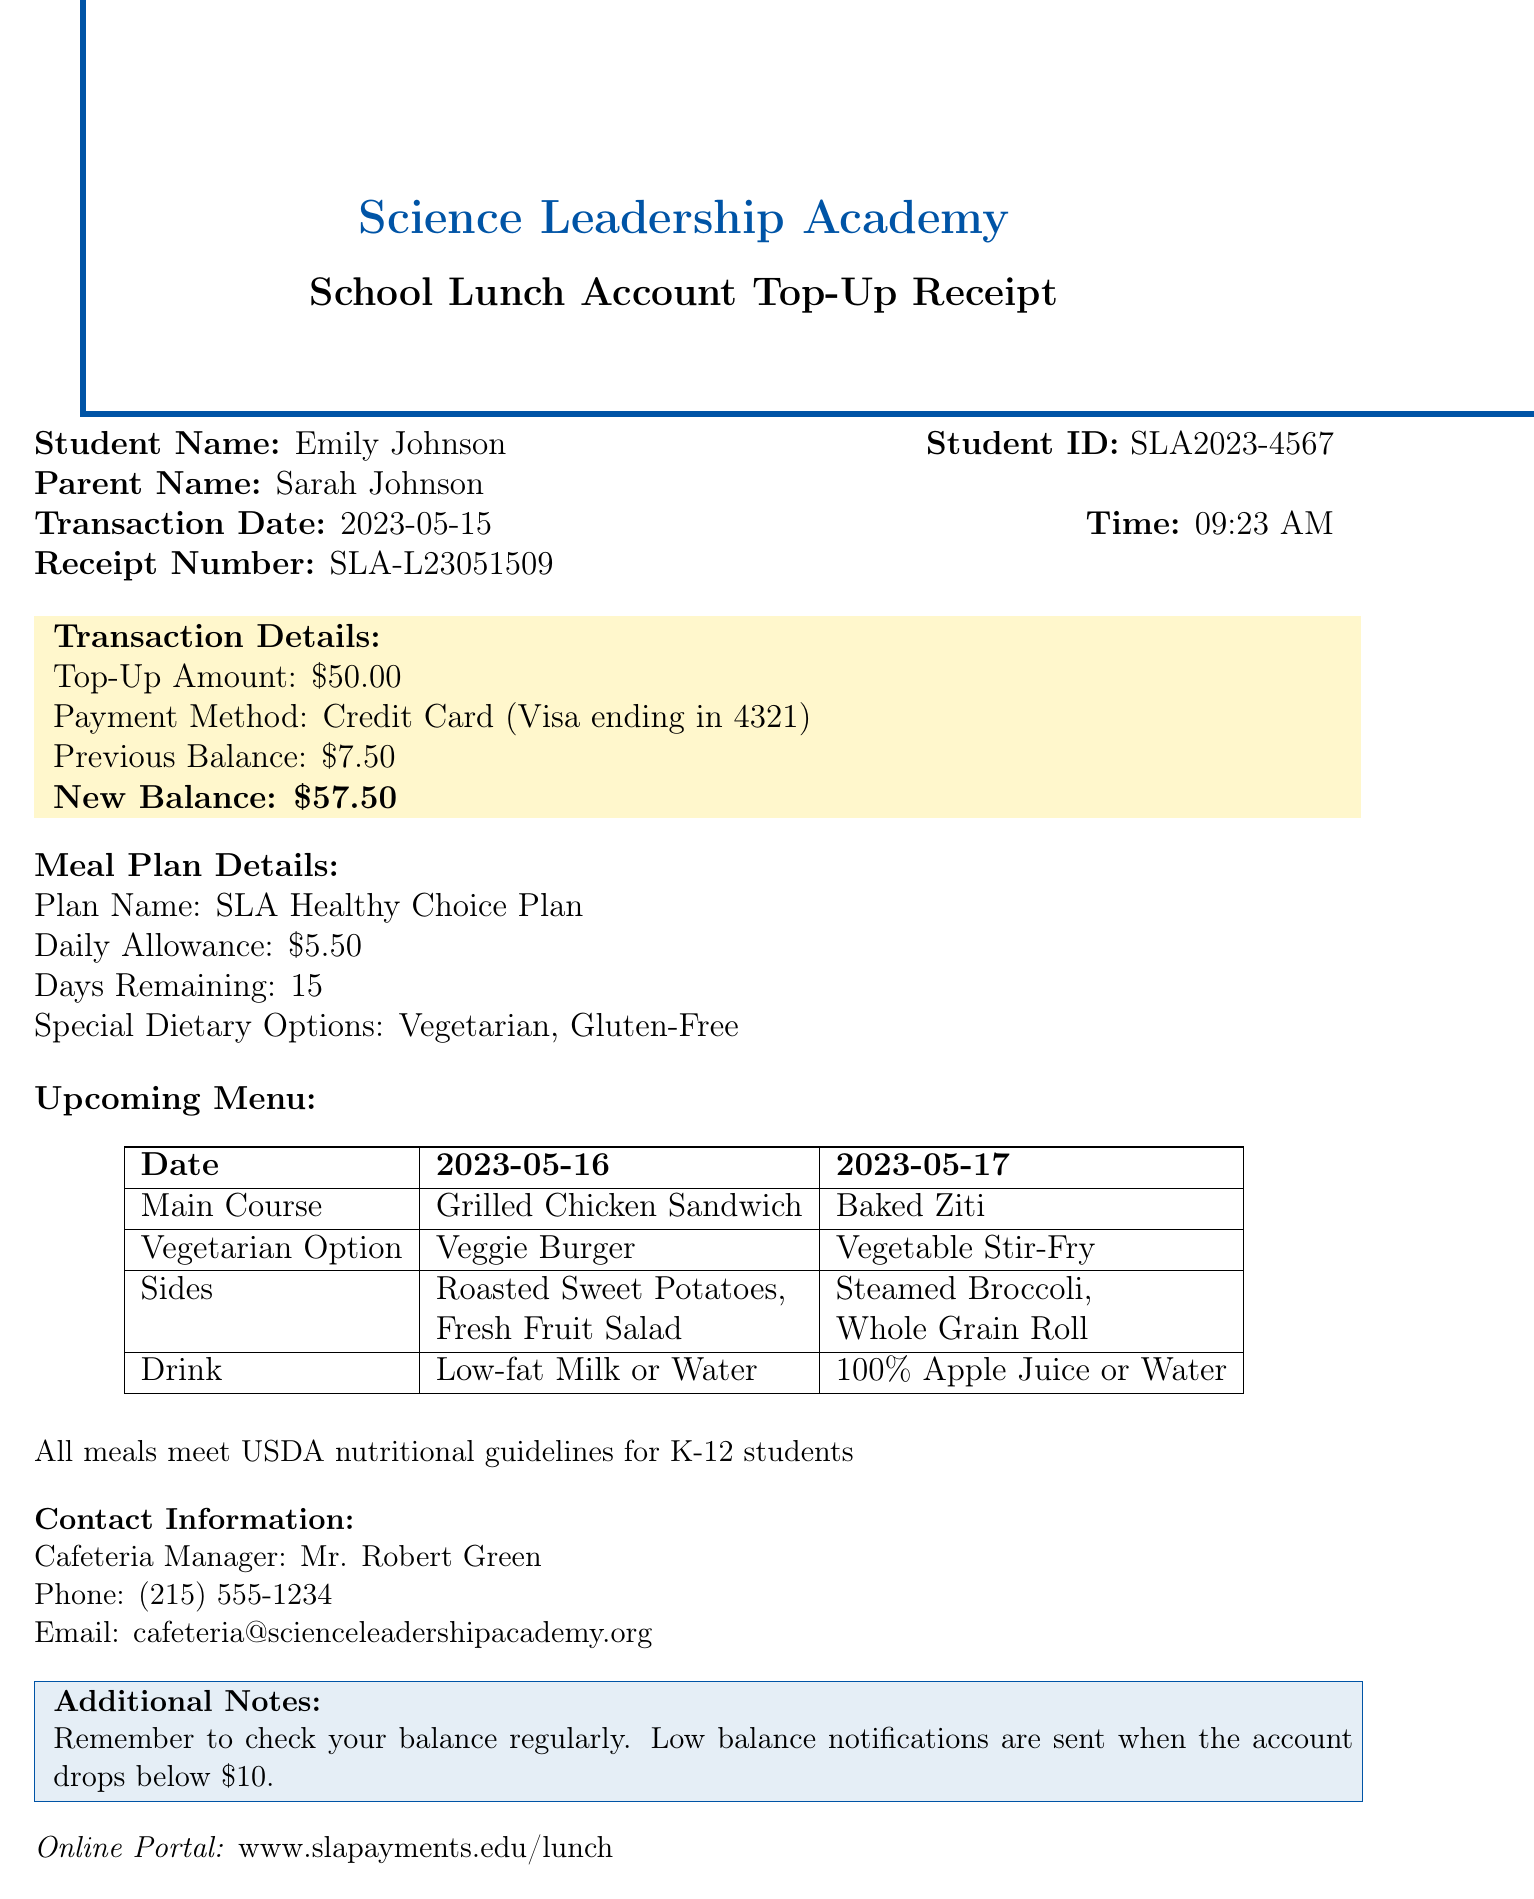What is the student's name? The student's name is mentioned directly in the document under "Student Name."
Answer: Emily Johnson What is the transaction date? The transaction date is provided under "Transaction Date" in the document.
Answer: 2023-05-15 How much was the top-up amount? The top-up amount can be found in the "Transaction Details" section of the document.
Answer: $50.00 What is the new balance after the top-up? The new balance is indicated in the "Transaction Details" section of the document.
Answer: $57.50 How many days remain on the meal plan? The number of days remaining is listed in the "Meal Plan Details" section.
Answer: 15 What are the vegetarian options for May 16? The vegetarian options for May 16 are noted in the "Upcoming Menu" section of the document.
Answer: Veggie Burger What is the contact number for the cafeteria manager? The contact number can be found in the "Contact Information" section of the document.
Answer: (215) 555-1234 What dietary options are available in the meal plan? The special dietary options are specified in the "Meal Plan Details."
Answer: Vegetarian, Gluten-Free When will low balance notifications be sent? The information regarding low balance notifications is mentioned in the "Additional Notes" section of the document.
Answer: When the account drops below $10 What is the online portal for lunch payments? The online portal is listed at the end of the document.
Answer: www.slapayments.edu/lunch 